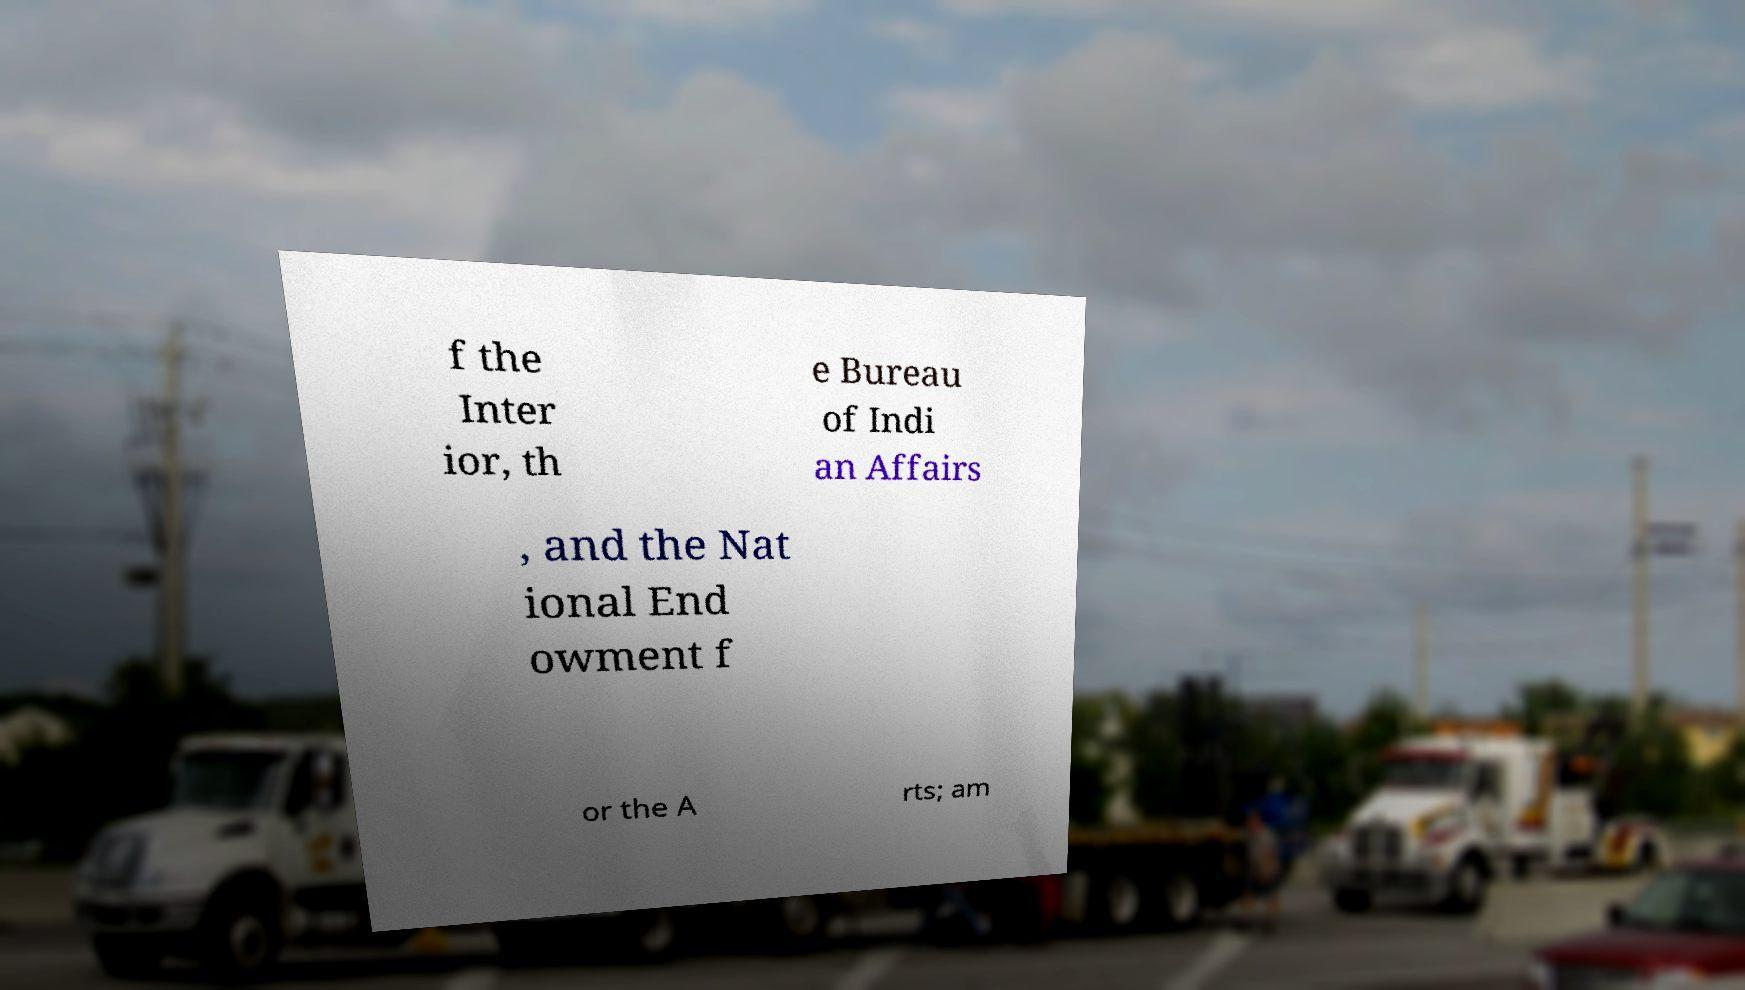I need the written content from this picture converted into text. Can you do that? f the Inter ior, th e Bureau of Indi an Affairs , and the Nat ional End owment f or the A rts; am 